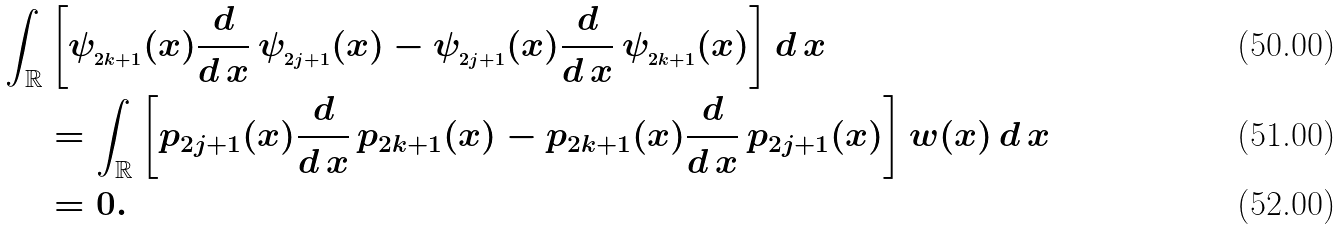Convert formula to latex. <formula><loc_0><loc_0><loc_500><loc_500>\int _ { \mathbb { R } } & \left [ \psi _ { _ { 2 k + 1 } } ( x ) \frac { d } { d \, x } \, \psi _ { _ { 2 j + 1 } } ( x ) - \psi _ { _ { 2 j + 1 } } ( x ) \frac { d } { d \, x } \, \psi _ { _ { 2 k + 1 } } ( x ) \right ] d \, x \\ & = \int _ { \mathbb { R } } \left [ p _ { 2 j + 1 } ( x ) \frac { d } { d \, x } \, p _ { 2 k + 1 } ( x ) - p _ { 2 k + 1 } ( x ) \frac { d } { d \, x } \, p _ { 2 j + 1 } ( x ) \right ] w ( x ) \, d \, x \\ & = 0 .</formula> 